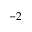<formula> <loc_0><loc_0><loc_500><loc_500>- 2</formula> 